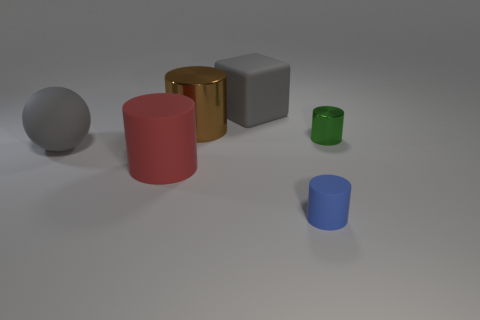Add 1 purple shiny cylinders. How many objects exist? 7 Subtract all balls. How many objects are left? 5 Add 4 large cyan things. How many large cyan things exist? 4 Subtract 0 red blocks. How many objects are left? 6 Subtract all purple spheres. Subtract all small blue cylinders. How many objects are left? 5 Add 4 large matte blocks. How many large matte blocks are left? 5 